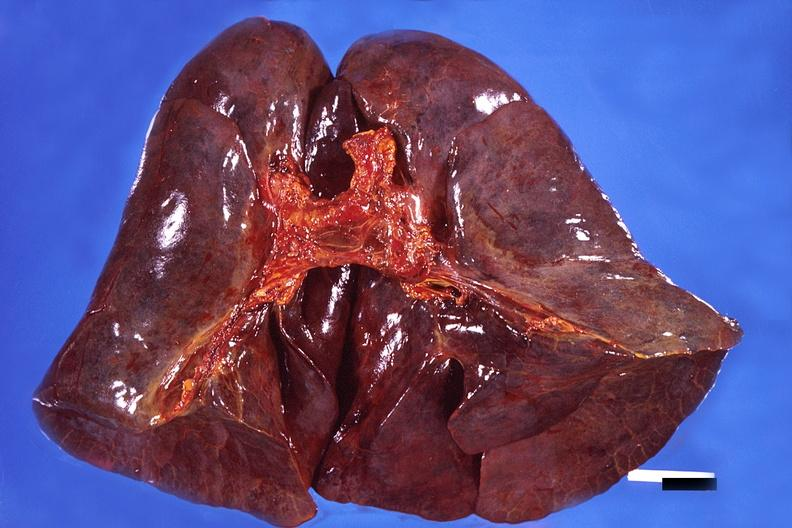s respiratory present?
Answer the question using a single word or phrase. Yes 